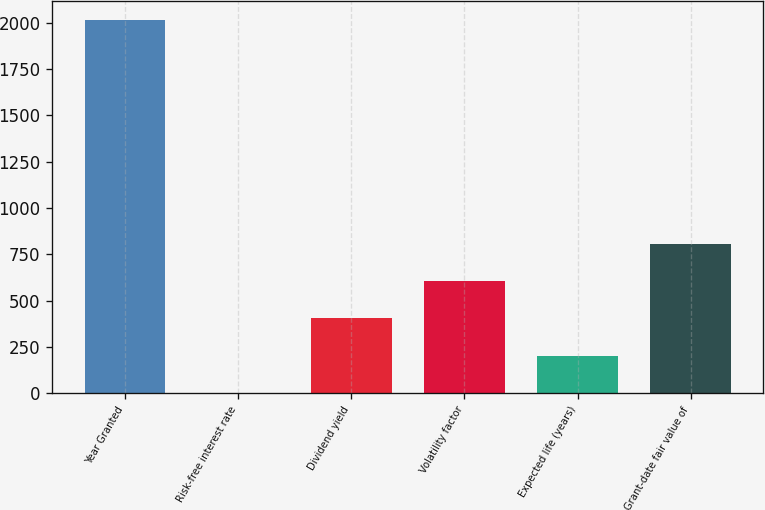Convert chart. <chart><loc_0><loc_0><loc_500><loc_500><bar_chart><fcel>Year Granted<fcel>Risk-free interest rate<fcel>Dividend yield<fcel>Volatility factor<fcel>Expected life (years)<fcel>Grant-date fair value of<nl><fcel>2016<fcel>0.8<fcel>403.84<fcel>605.36<fcel>202.32<fcel>806.88<nl></chart> 